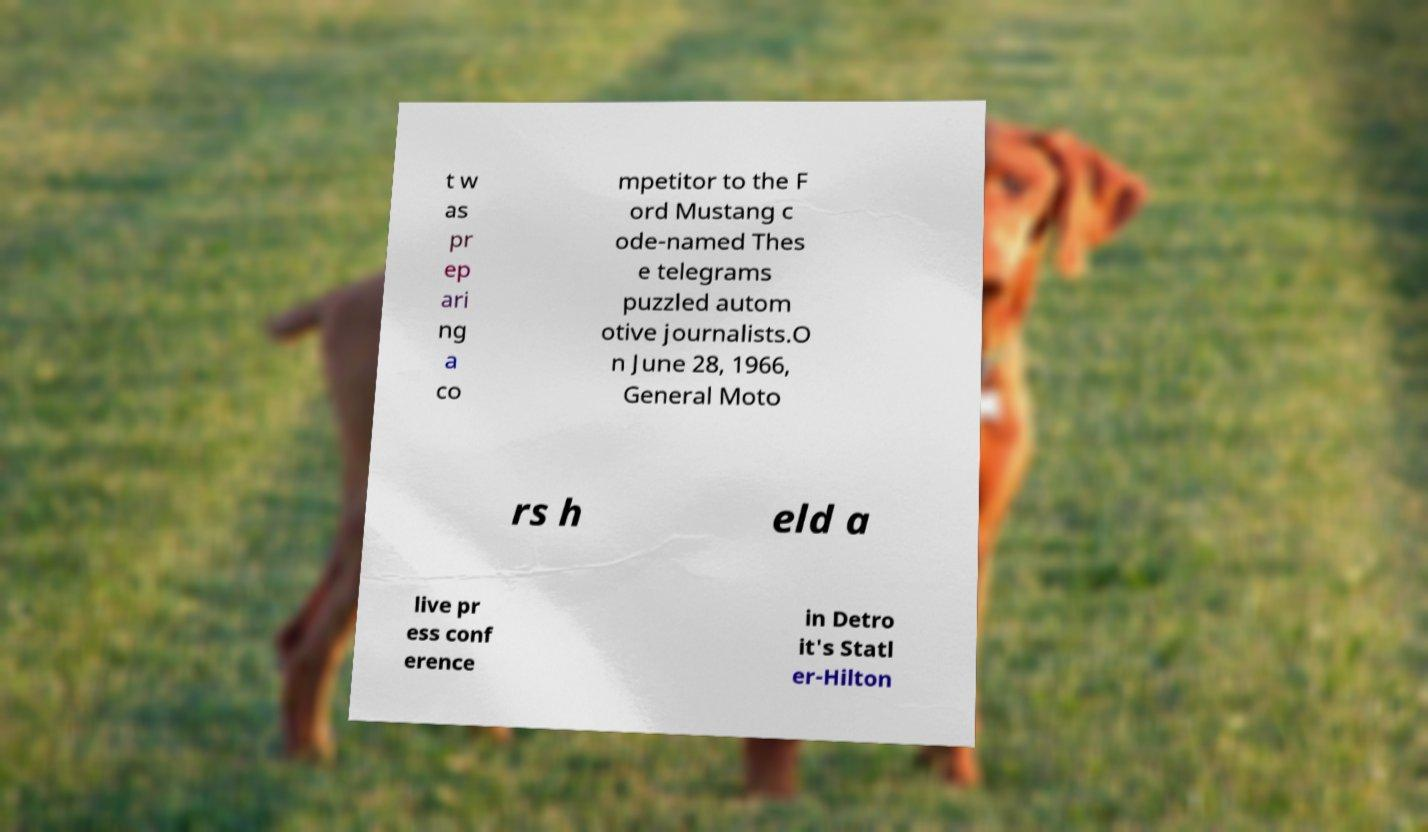Please read and relay the text visible in this image. What does it say? t w as pr ep ari ng a co mpetitor to the F ord Mustang c ode-named Thes e telegrams puzzled autom otive journalists.O n June 28, 1966, General Moto rs h eld a live pr ess conf erence in Detro it's Statl er-Hilton 